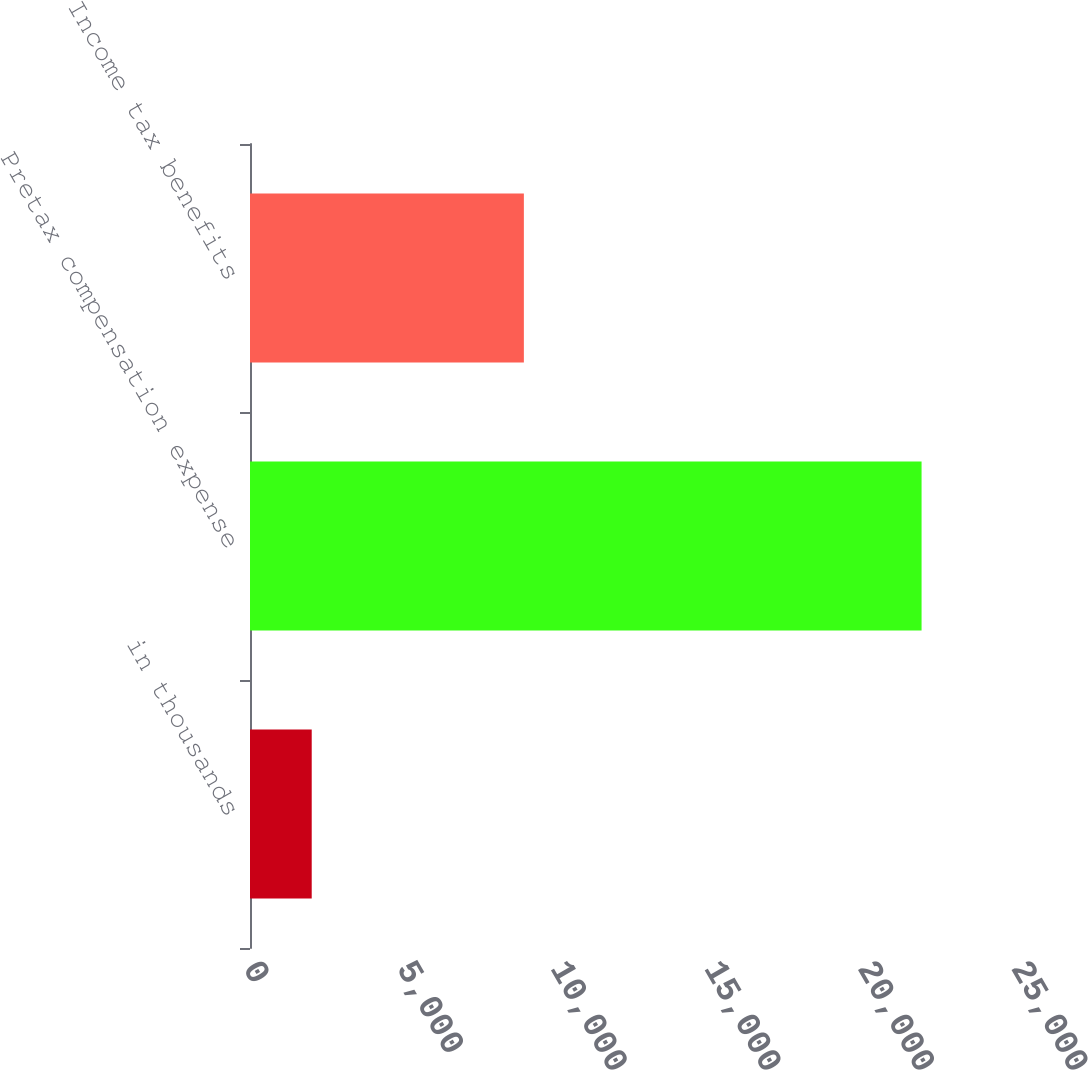Convert chart to OTSL. <chart><loc_0><loc_0><loc_500><loc_500><bar_chart><fcel>in thousands<fcel>Pretax compensation expense<fcel>Income tax benefits<nl><fcel>2009<fcel>21861<fcel>8915<nl></chart> 